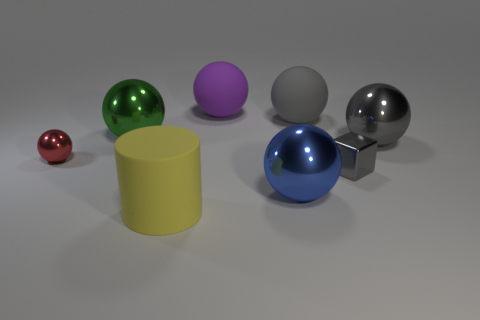Is the blue sphere the same size as the cube?
Provide a short and direct response. No. Is the number of big blue objects that are right of the large gray metal object less than the number of big gray things that are in front of the green thing?
Ensure brevity in your answer.  Yes. The gray block has what size?
Offer a terse response. Small. How many large things are red spheres or cyan metal spheres?
Your answer should be very brief. 0. Do the blue ball and the gray thing in front of the big gray metal object have the same size?
Your response must be concise. No. Is there any other thing that has the same shape as the tiny gray thing?
Ensure brevity in your answer.  No. What number of green metallic cubes are there?
Make the answer very short. 0. What number of red things are metallic balls or rubber cylinders?
Your answer should be very brief. 1. Are the tiny object right of the big purple ball and the large cylinder made of the same material?
Your answer should be very brief. No. How many other objects are the same material as the big blue sphere?
Offer a terse response. 4. 